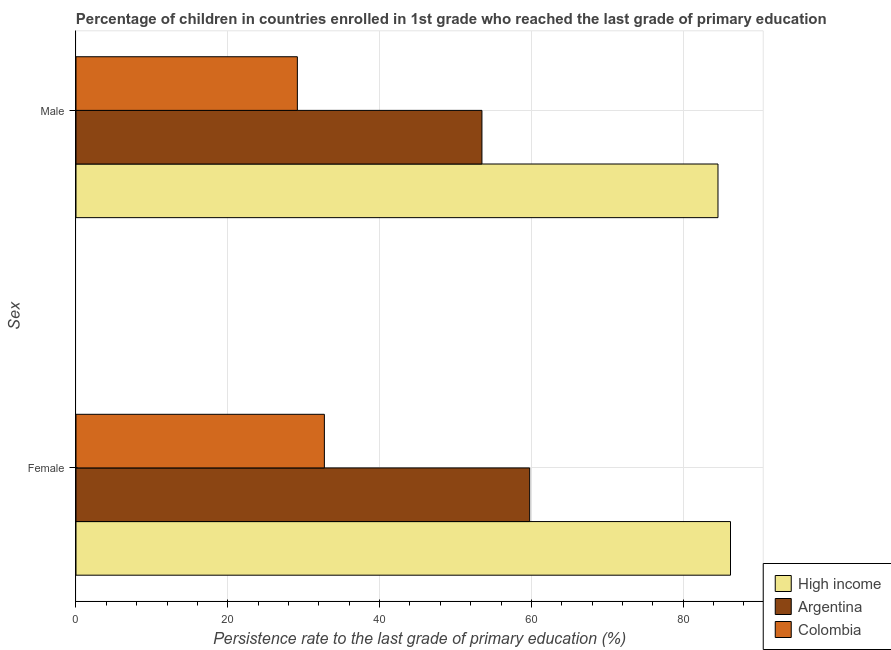How many different coloured bars are there?
Make the answer very short. 3. How many groups of bars are there?
Your response must be concise. 2. What is the persistence rate of male students in High income?
Keep it short and to the point. 84.58. Across all countries, what is the maximum persistence rate of female students?
Your response must be concise. 86.23. Across all countries, what is the minimum persistence rate of female students?
Give a very brief answer. 32.72. What is the total persistence rate of male students in the graph?
Your answer should be very brief. 167.23. What is the difference between the persistence rate of male students in Colombia and that in Argentina?
Offer a terse response. -24.32. What is the difference between the persistence rate of female students in Argentina and the persistence rate of male students in High income?
Provide a short and direct response. -24.81. What is the average persistence rate of female students per country?
Offer a very short reply. 59.58. What is the difference between the persistence rate of female students and persistence rate of male students in High income?
Ensure brevity in your answer.  1.65. In how many countries, is the persistence rate of female students greater than 24 %?
Offer a terse response. 3. What is the ratio of the persistence rate of male students in Argentina to that in Colombia?
Provide a succinct answer. 1.83. Is the persistence rate of male students in Colombia less than that in Argentina?
Give a very brief answer. Yes. In how many countries, is the persistence rate of female students greater than the average persistence rate of female students taken over all countries?
Your answer should be very brief. 2. What does the 2nd bar from the bottom in Male represents?
Make the answer very short. Argentina. Are all the bars in the graph horizontal?
Your answer should be very brief. Yes. How many countries are there in the graph?
Offer a terse response. 3. What is the difference between two consecutive major ticks on the X-axis?
Your response must be concise. 20. Are the values on the major ticks of X-axis written in scientific E-notation?
Provide a succinct answer. No. Does the graph contain any zero values?
Make the answer very short. No. Does the graph contain grids?
Your response must be concise. Yes. How are the legend labels stacked?
Make the answer very short. Vertical. What is the title of the graph?
Your response must be concise. Percentage of children in countries enrolled in 1st grade who reached the last grade of primary education. Does "Belgium" appear as one of the legend labels in the graph?
Offer a very short reply. No. What is the label or title of the X-axis?
Offer a very short reply. Persistence rate to the last grade of primary education (%). What is the label or title of the Y-axis?
Provide a short and direct response. Sex. What is the Persistence rate to the last grade of primary education (%) in High income in Female?
Provide a short and direct response. 86.23. What is the Persistence rate to the last grade of primary education (%) in Argentina in Female?
Make the answer very short. 59.77. What is the Persistence rate to the last grade of primary education (%) in Colombia in Female?
Your response must be concise. 32.72. What is the Persistence rate to the last grade of primary education (%) in High income in Male?
Make the answer very short. 84.58. What is the Persistence rate to the last grade of primary education (%) in Argentina in Male?
Your response must be concise. 53.48. What is the Persistence rate to the last grade of primary education (%) in Colombia in Male?
Offer a terse response. 29.16. Across all Sex, what is the maximum Persistence rate to the last grade of primary education (%) of High income?
Your response must be concise. 86.23. Across all Sex, what is the maximum Persistence rate to the last grade of primary education (%) in Argentina?
Keep it short and to the point. 59.77. Across all Sex, what is the maximum Persistence rate to the last grade of primary education (%) of Colombia?
Make the answer very short. 32.72. Across all Sex, what is the minimum Persistence rate to the last grade of primary education (%) of High income?
Provide a succinct answer. 84.58. Across all Sex, what is the minimum Persistence rate to the last grade of primary education (%) of Argentina?
Your response must be concise. 53.48. Across all Sex, what is the minimum Persistence rate to the last grade of primary education (%) of Colombia?
Give a very brief answer. 29.16. What is the total Persistence rate to the last grade of primary education (%) of High income in the graph?
Provide a short and direct response. 170.81. What is the total Persistence rate to the last grade of primary education (%) in Argentina in the graph?
Your response must be concise. 113.25. What is the total Persistence rate to the last grade of primary education (%) in Colombia in the graph?
Your answer should be compact. 61.89. What is the difference between the Persistence rate to the last grade of primary education (%) of High income in Female and that in Male?
Ensure brevity in your answer.  1.65. What is the difference between the Persistence rate to the last grade of primary education (%) in Argentina in Female and that in Male?
Give a very brief answer. 6.29. What is the difference between the Persistence rate to the last grade of primary education (%) in Colombia in Female and that in Male?
Your response must be concise. 3.56. What is the difference between the Persistence rate to the last grade of primary education (%) in High income in Female and the Persistence rate to the last grade of primary education (%) in Argentina in Male?
Your answer should be compact. 32.75. What is the difference between the Persistence rate to the last grade of primary education (%) of High income in Female and the Persistence rate to the last grade of primary education (%) of Colombia in Male?
Keep it short and to the point. 57.07. What is the difference between the Persistence rate to the last grade of primary education (%) in Argentina in Female and the Persistence rate to the last grade of primary education (%) in Colombia in Male?
Your answer should be compact. 30.61. What is the average Persistence rate to the last grade of primary education (%) of High income per Sex?
Your answer should be very brief. 85.41. What is the average Persistence rate to the last grade of primary education (%) in Argentina per Sex?
Your answer should be compact. 56.63. What is the average Persistence rate to the last grade of primary education (%) of Colombia per Sex?
Your answer should be compact. 30.94. What is the difference between the Persistence rate to the last grade of primary education (%) of High income and Persistence rate to the last grade of primary education (%) of Argentina in Female?
Give a very brief answer. 26.46. What is the difference between the Persistence rate to the last grade of primary education (%) in High income and Persistence rate to the last grade of primary education (%) in Colombia in Female?
Offer a terse response. 53.51. What is the difference between the Persistence rate to the last grade of primary education (%) of Argentina and Persistence rate to the last grade of primary education (%) of Colombia in Female?
Provide a short and direct response. 27.05. What is the difference between the Persistence rate to the last grade of primary education (%) in High income and Persistence rate to the last grade of primary education (%) in Argentina in Male?
Keep it short and to the point. 31.1. What is the difference between the Persistence rate to the last grade of primary education (%) of High income and Persistence rate to the last grade of primary education (%) of Colombia in Male?
Ensure brevity in your answer.  55.42. What is the difference between the Persistence rate to the last grade of primary education (%) in Argentina and Persistence rate to the last grade of primary education (%) in Colombia in Male?
Provide a succinct answer. 24.32. What is the ratio of the Persistence rate to the last grade of primary education (%) of High income in Female to that in Male?
Your answer should be very brief. 1.02. What is the ratio of the Persistence rate to the last grade of primary education (%) of Argentina in Female to that in Male?
Ensure brevity in your answer.  1.12. What is the ratio of the Persistence rate to the last grade of primary education (%) in Colombia in Female to that in Male?
Make the answer very short. 1.12. What is the difference between the highest and the second highest Persistence rate to the last grade of primary education (%) of High income?
Provide a short and direct response. 1.65. What is the difference between the highest and the second highest Persistence rate to the last grade of primary education (%) of Argentina?
Your answer should be very brief. 6.29. What is the difference between the highest and the second highest Persistence rate to the last grade of primary education (%) in Colombia?
Your answer should be very brief. 3.56. What is the difference between the highest and the lowest Persistence rate to the last grade of primary education (%) in High income?
Offer a terse response. 1.65. What is the difference between the highest and the lowest Persistence rate to the last grade of primary education (%) of Argentina?
Your answer should be compact. 6.29. What is the difference between the highest and the lowest Persistence rate to the last grade of primary education (%) in Colombia?
Make the answer very short. 3.56. 